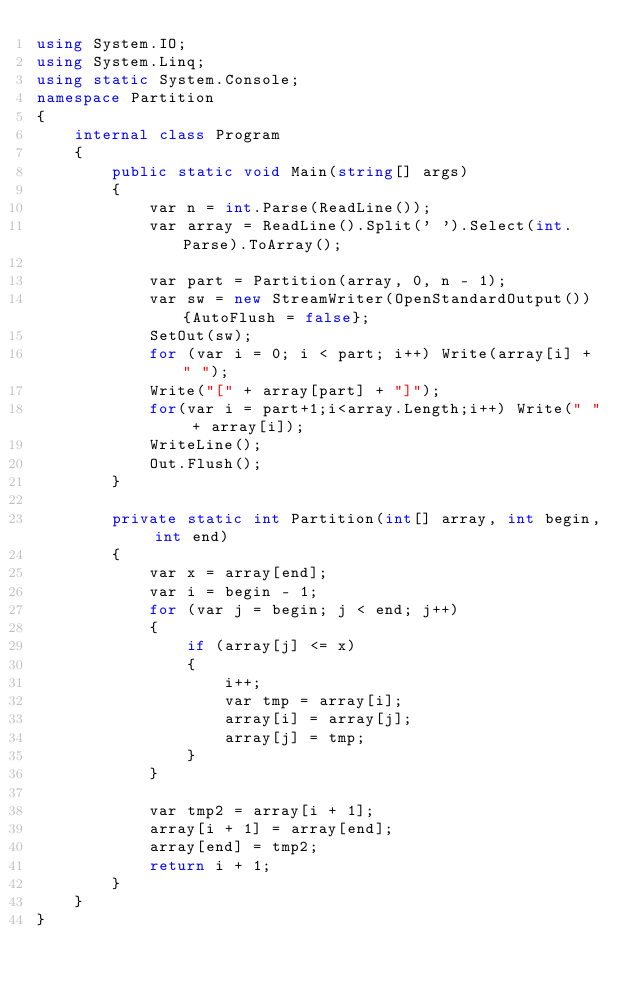<code> <loc_0><loc_0><loc_500><loc_500><_C#_>using System.IO;
using System.Linq;
using static System.Console;
namespace Partition
{
    internal class Program
    {
        public static void Main(string[] args)
        {
            var n = int.Parse(ReadLine());
            var array = ReadLine().Split(' ').Select(int.Parse).ToArray();

            var part = Partition(array, 0, n - 1);
            var sw = new StreamWriter(OpenStandardOutput()) {AutoFlush = false};
            SetOut(sw);
            for (var i = 0; i < part; i++) Write(array[i] + " ");
            Write("[" + array[part] + "]");
            for(var i = part+1;i<array.Length;i++) Write(" " + array[i]);
            WriteLine();
            Out.Flush();
        }

        private static int Partition(int[] array, int begin, int end)
        {
            var x = array[end];
            var i = begin - 1;
            for (var j = begin; j < end; j++)
            {
                if (array[j] <= x)
                {
                    i++;
                    var tmp = array[i];
                    array[i] = array[j];
                    array[j] = tmp;
                }
            }

            var tmp2 = array[i + 1];
            array[i + 1] = array[end];
            array[end] = tmp2;
            return i + 1;
        }
    }
}
</code> 